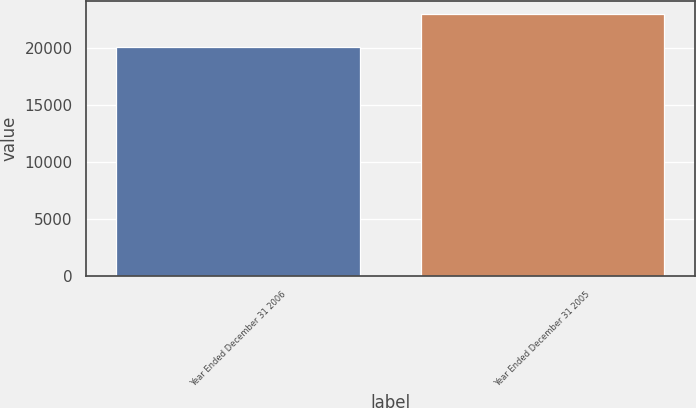Convert chart to OTSL. <chart><loc_0><loc_0><loc_500><loc_500><bar_chart><fcel>Year Ended December 31 2006<fcel>Year Ended December 31 2005<nl><fcel>20061<fcel>22958<nl></chart> 